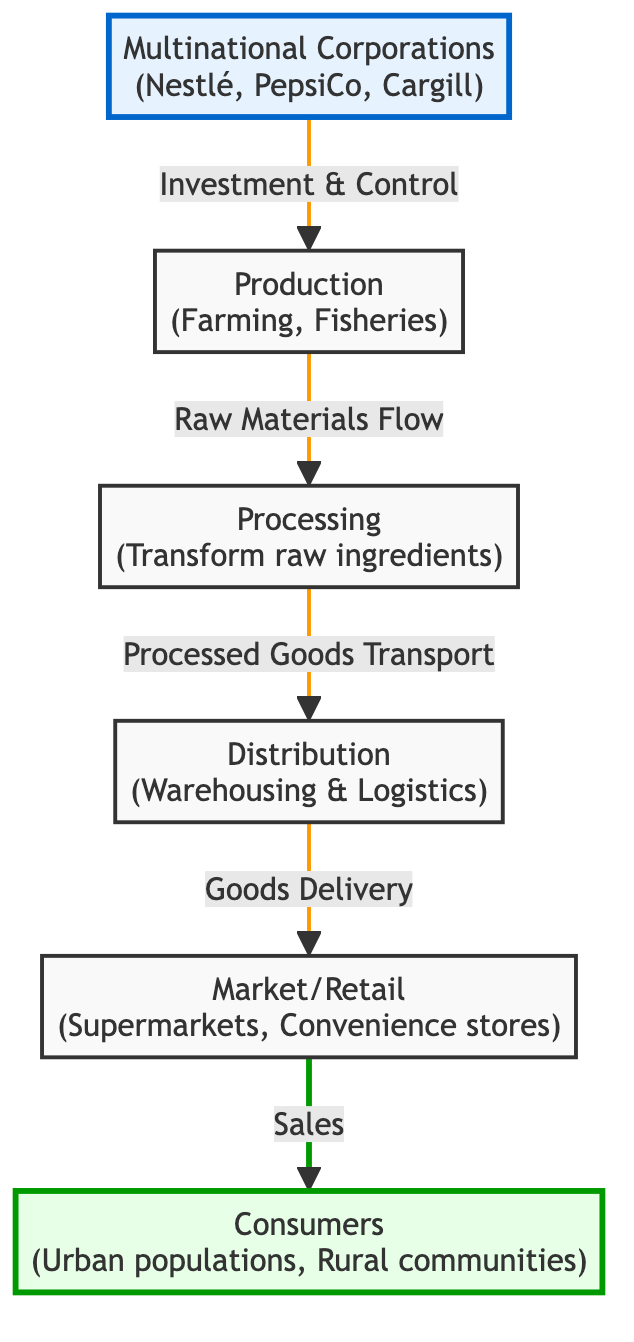What are the main multinational corporations depicted? The diagram lists three main multinational corporations: Nestlé, PepsiCo, and Cargill, which are described at the top as the sources of corporate influence.
Answer: Nestlé, PepsiCo, Cargill How do goods flow from production to consumers? The flow of goods starts from production, moving through processing to distribution, then to market/retail, and finally reaching consumers, forming a linear path of procurement to sale.
Answer: Production → Processing → Distribution → Market/Retail → Consumers What type of logistics is involved between processing and market/retail? The diagram specifically states that the logistics involved in this transition involves "Goods Delivery," which is a key aspect in ensuring products reach the retailers effectively.
Answer: Goods Delivery Which demographic is directly associated with the "Consumers" node? The consumers are divided into two categories: urban populations and rural communities, which are shown in the diagram as the receiving end of the food distribution chain.
Answer: Urban populations, Rural communities How many nodes are there in total in the diagram? Counting all unique nodes presented in the diagram, we find a total of six nodes: Multinational Corporations, Production, Processing, Distribution, Market/Retail, and Consumers.
Answer: Six Which segment of the flowchart emphasizes corporate influence? The "Multinational Corporations" node emphasizes corporate influence, showing its position at the beginning of the chain and linking directly to production, indicating control over the flow of food products.
Answer: Multinational Corporations What role does the "Processing" node play in the food chain? The processing node serves the essential function of transforming raw ingredients into processed goods, facilitating the flow of goods towards distribution.
Answer: Transform raw ingredients How is "Investment & Control" characterized in the flowchart? The relationship identified as "Investment & Control" connects multinational corporations with the production stage, illustrating that corporates are directly involved in the initial sourcing of agriculture and fisheries.
Answer: Investment & Control What connection is depicted between "Distribution" and "Market/Retail"? The connection described between these two sections is that of "Goods Delivery," which highlights the logistical link that ensures products are transported from distribution centers to retail outlets for consumer access.
Answer: Goods Delivery 